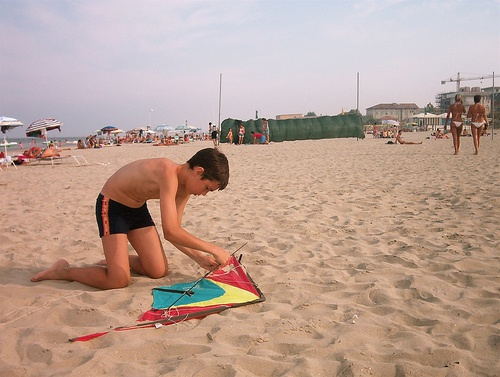Describe the objects in this image and their specific colors. I can see people in darkgray, brown, black, and maroon tones, kite in darkgray, tan, teal, brown, and khaki tones, people in darkgray, maroon, brown, and gray tones, people in darkgray, maroon, brown, and tan tones, and umbrella in darkgray, lightgray, tan, and gray tones in this image. 